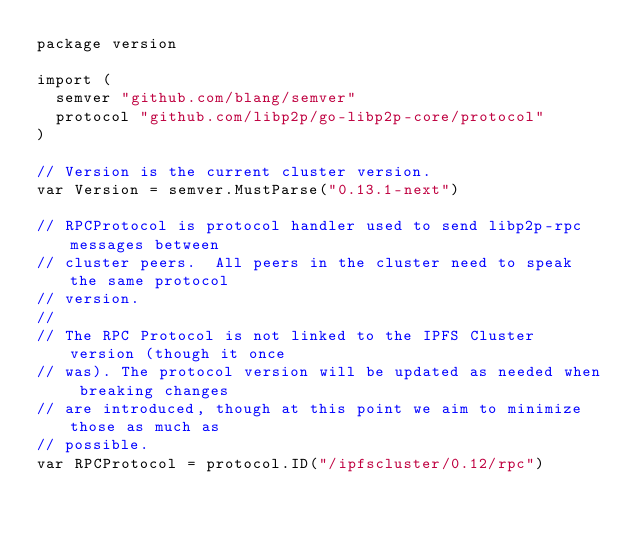<code> <loc_0><loc_0><loc_500><loc_500><_Go_>package version

import (
	semver "github.com/blang/semver"
	protocol "github.com/libp2p/go-libp2p-core/protocol"
)

// Version is the current cluster version.
var Version = semver.MustParse("0.13.1-next")

// RPCProtocol is protocol handler used to send libp2p-rpc messages between
// cluster peers.  All peers in the cluster need to speak the same protocol
// version.
//
// The RPC Protocol is not linked to the IPFS Cluster version (though it once
// was). The protocol version will be updated as needed when breaking changes
// are introduced, though at this point we aim to minimize those as much as
// possible.
var RPCProtocol = protocol.ID("/ipfscluster/0.12/rpc")
</code> 